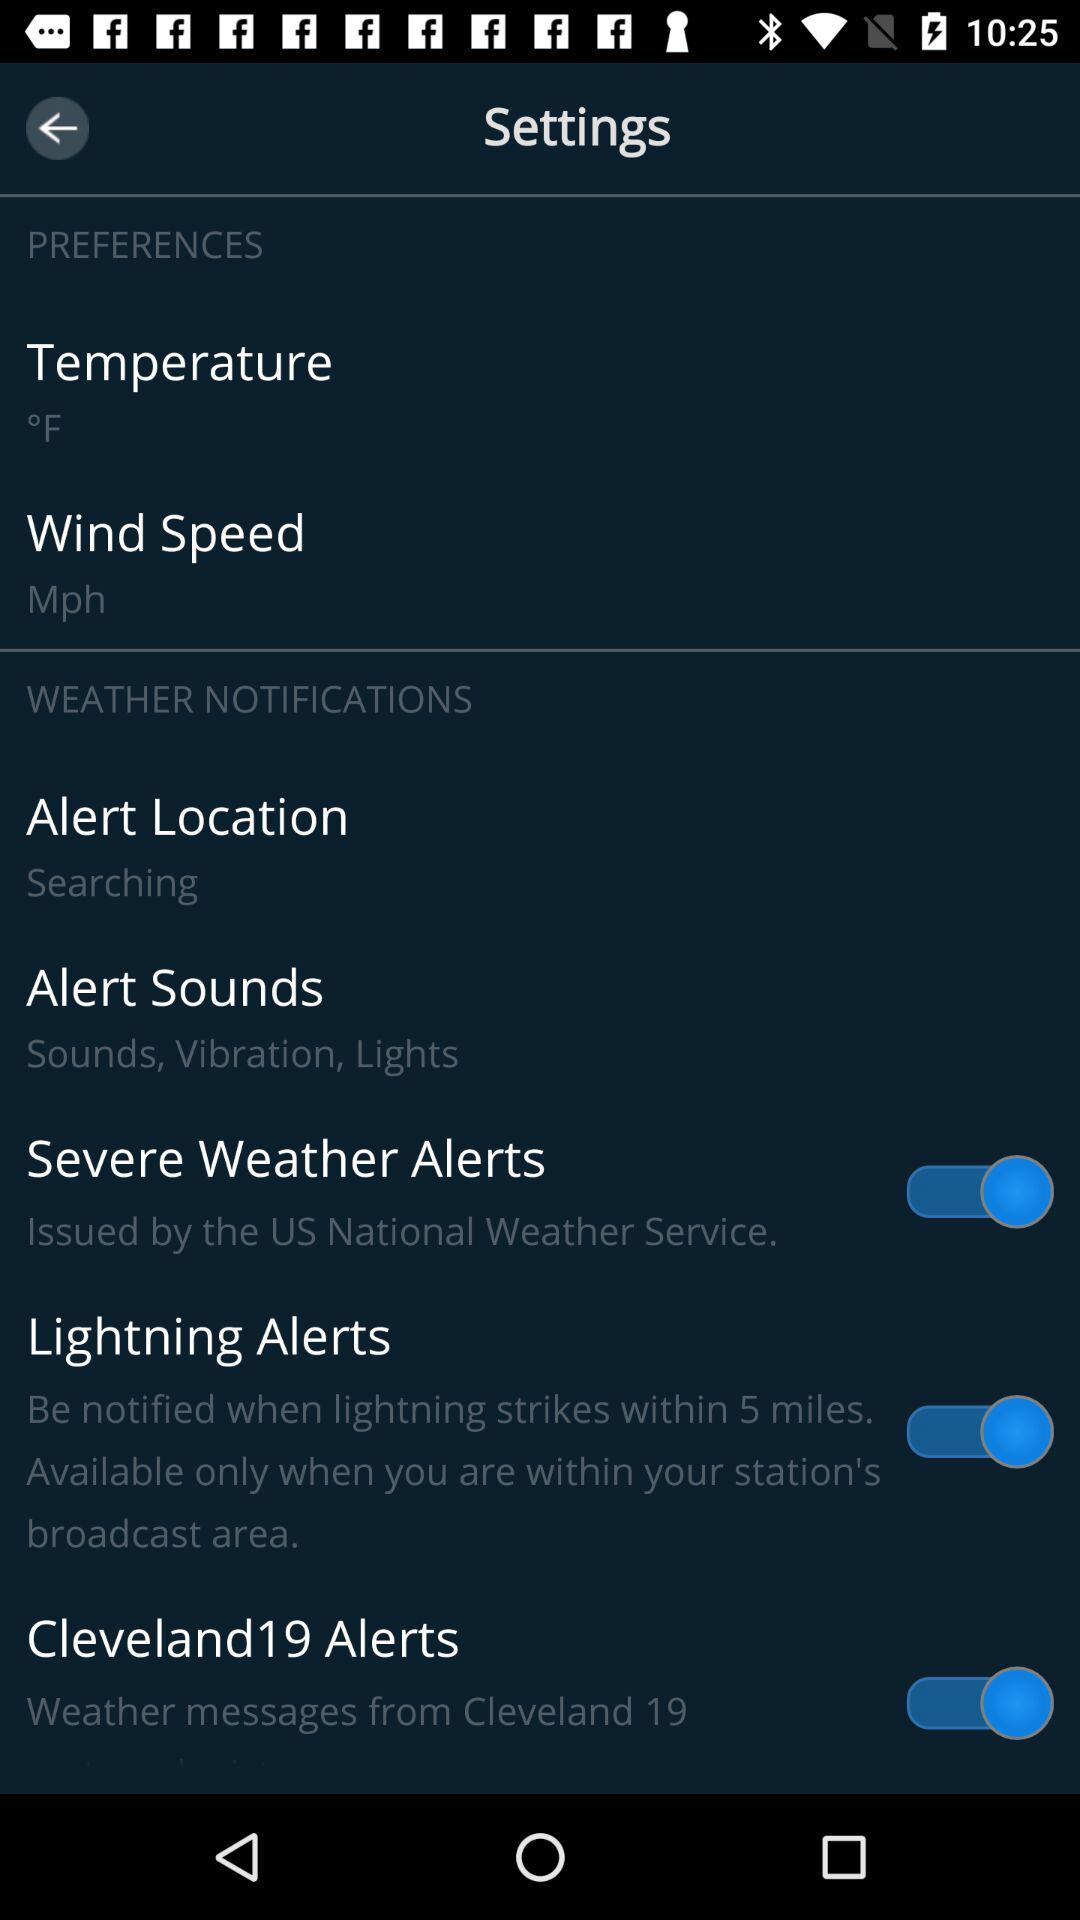What is the unit of temperature? The unit of temperature is °F. 